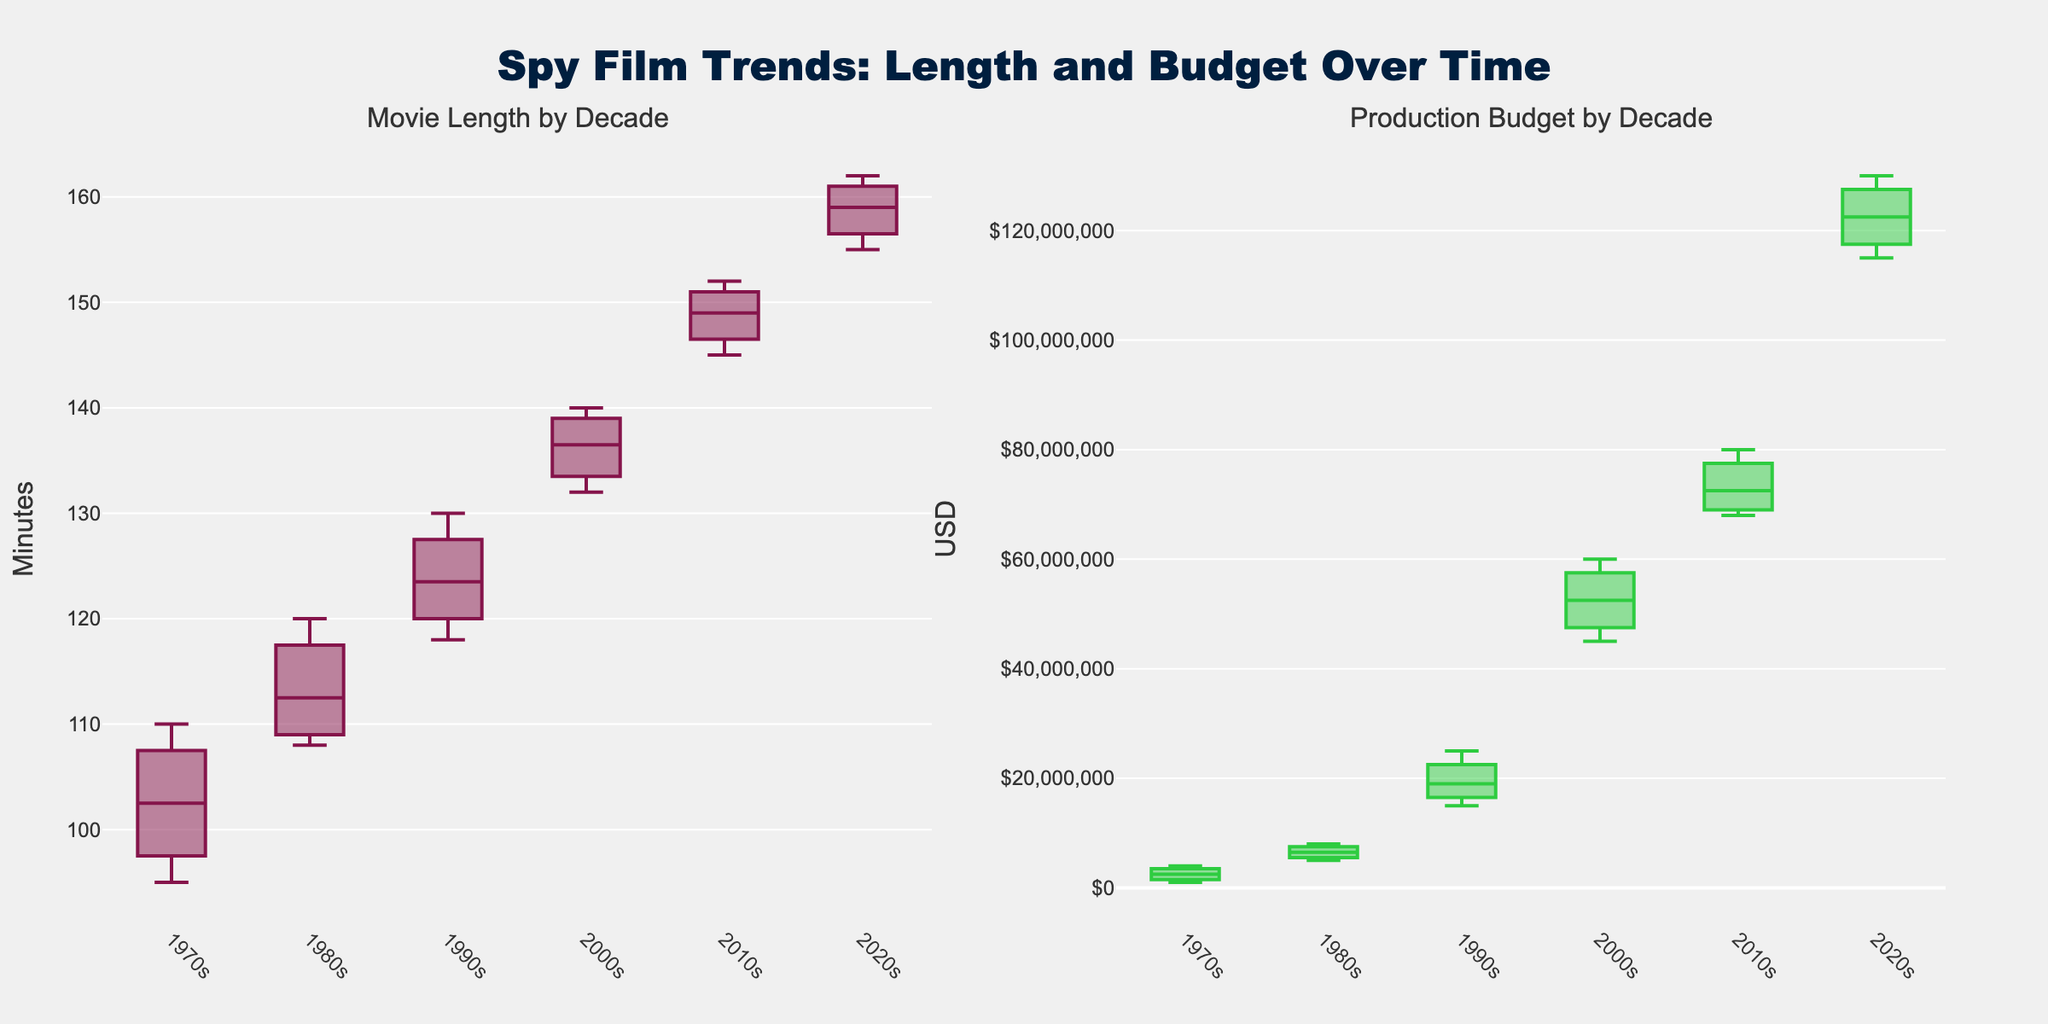How many decades are represented in the figure? By counting the unique categories on the x-axis representations under the box plots, we can identify the number of decades shown in the figure.
Answer: 6 In which decade was the average movie length the longest? By visually comparing the central lines (medians) of the box plots in the "Movie Length by Decade" subplot, we can determine which decade has the highest median value for movie length.
Answer: 2020s What is the median production budget in the 2010s? To find the median production budget for the 2010s, we need to look at the central line inside the box representing the 2010s category in the "Production Budget by Decade" subplot.
Answer: $73,000,000 Which decade has the greatest range in movie length? The range of movie length for each decade is indicated by the distance between the top whisker and the bottom whisker of the box plot. Identifying the largest distance gives us the decade with the greatest range.
Answer: 2020s How do the average production budgets compare between the 1980s and the 2000s? To compare the average production budgets, we should look at the central lines (medians) in the "Production Budget by Decade" box plots for the 1980s and 2000s. The decade with the higher median indicates a higher average budget.
Answer: 2000s has a higher average budget Which subplot shows a greater overall increase in values from 1970s to 2020s? By comparing the overall vertical shifts in the positions of the box plots from 1970s to 2020s in both subplots, we can see which subplot has more significant increases. The subplot with higher values in the 2020s relative to the 1970s indicates a greater increase.
Answer: Production Budget by Decade What similarities can you observe between the box plots for movie length and production budget in terms of trends over the decades? By comparing the general trends seen in both subplots, we can observe common patterns such as increasing or decreasing medians, spreads, and ranges over the decades in both the movie length and production budget.
Answer: Both show increasing medians and ranges Which decade shows the most variation in production budget? Variation is indicated by the interquartile range (IQR), which is the distance between the bottom and top edges of the box. The decade with the widest box plot in the "Production Budget by Decade" subplot indicates the most variation.
Answer: 2020s How does the movie length in the 1990s compare to that in the 1970s? To compare the movie lengths, we need to look at the median lines of the box plots for the 1990s and 1970s in the "Movie Length by Decade" subplot. The decade with the higher median indicates a longer average movie length.
Answer: 1990s What can you infer about the trends of movie production budgets over the decades? By examining the shifts in median lines and the spread of the box plots over the decades in the "Production Budget by Decade" subplot, we can infer general trends like gradual increases, stability, or significant jumps.
Answer: Increasing over decades 